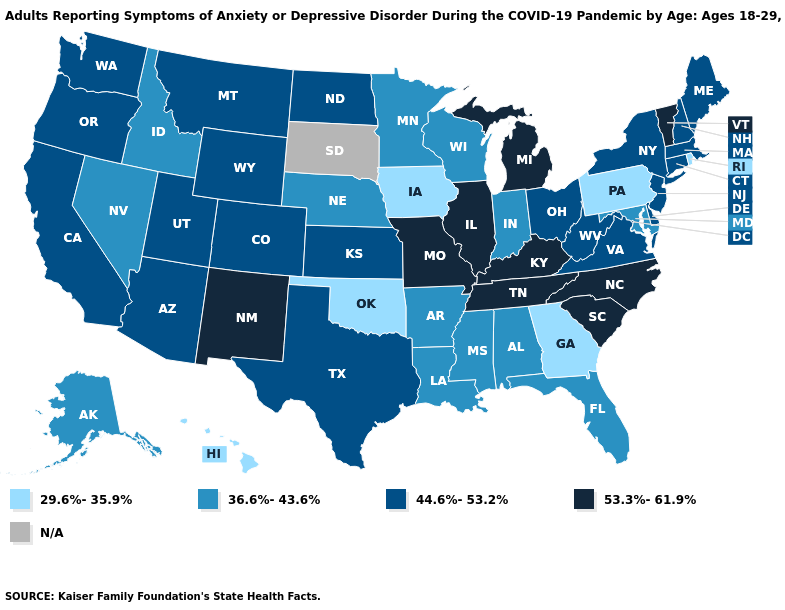Among the states that border Oklahoma , does Texas have the highest value?
Concise answer only. No. What is the lowest value in the USA?
Short answer required. 29.6%-35.9%. Does the map have missing data?
Concise answer only. Yes. Which states have the lowest value in the West?
Write a very short answer. Hawaii. Does New Hampshire have the highest value in the Northeast?
Write a very short answer. No. What is the lowest value in states that border Mississippi?
Answer briefly. 36.6%-43.6%. How many symbols are there in the legend?
Give a very brief answer. 5. Which states hav the highest value in the Northeast?
Concise answer only. Vermont. Name the states that have a value in the range N/A?
Concise answer only. South Dakota. Does Tennessee have the lowest value in the USA?
Quick response, please. No. What is the value of New Hampshire?
Write a very short answer. 44.6%-53.2%. Does the map have missing data?
Concise answer only. Yes. Among the states that border Colorado , does Oklahoma have the lowest value?
Answer briefly. Yes. Which states have the lowest value in the USA?
Give a very brief answer. Georgia, Hawaii, Iowa, Oklahoma, Pennsylvania, Rhode Island. Does the first symbol in the legend represent the smallest category?
Short answer required. Yes. 